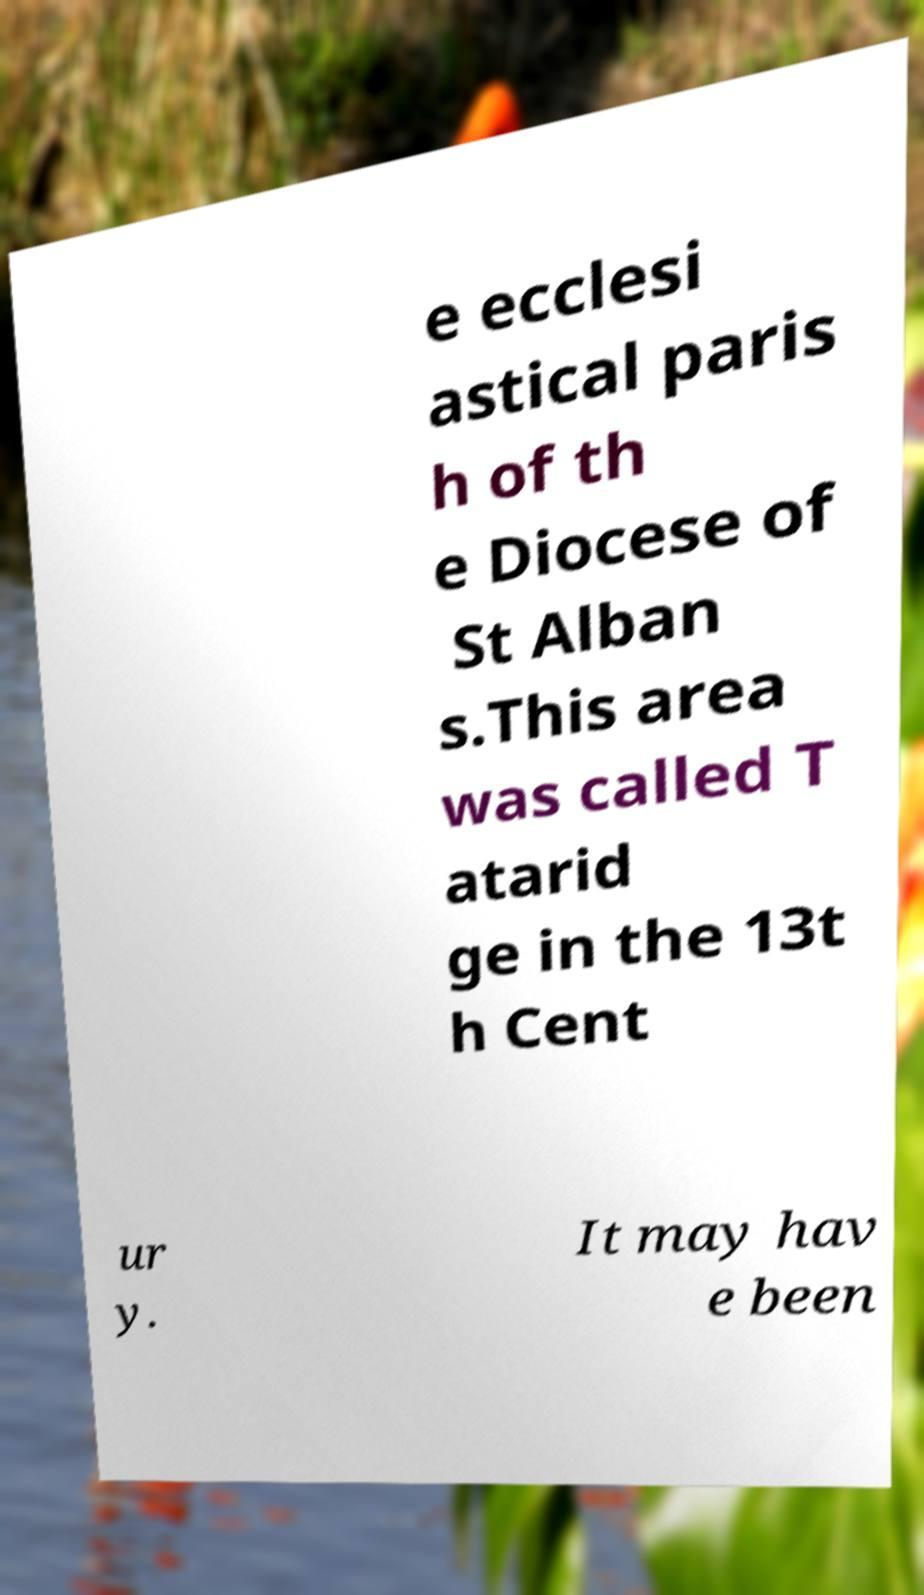What messages or text are displayed in this image? I need them in a readable, typed format. e ecclesi astical paris h of th e Diocese of St Alban s.This area was called T atarid ge in the 13t h Cent ur y. It may hav e been 